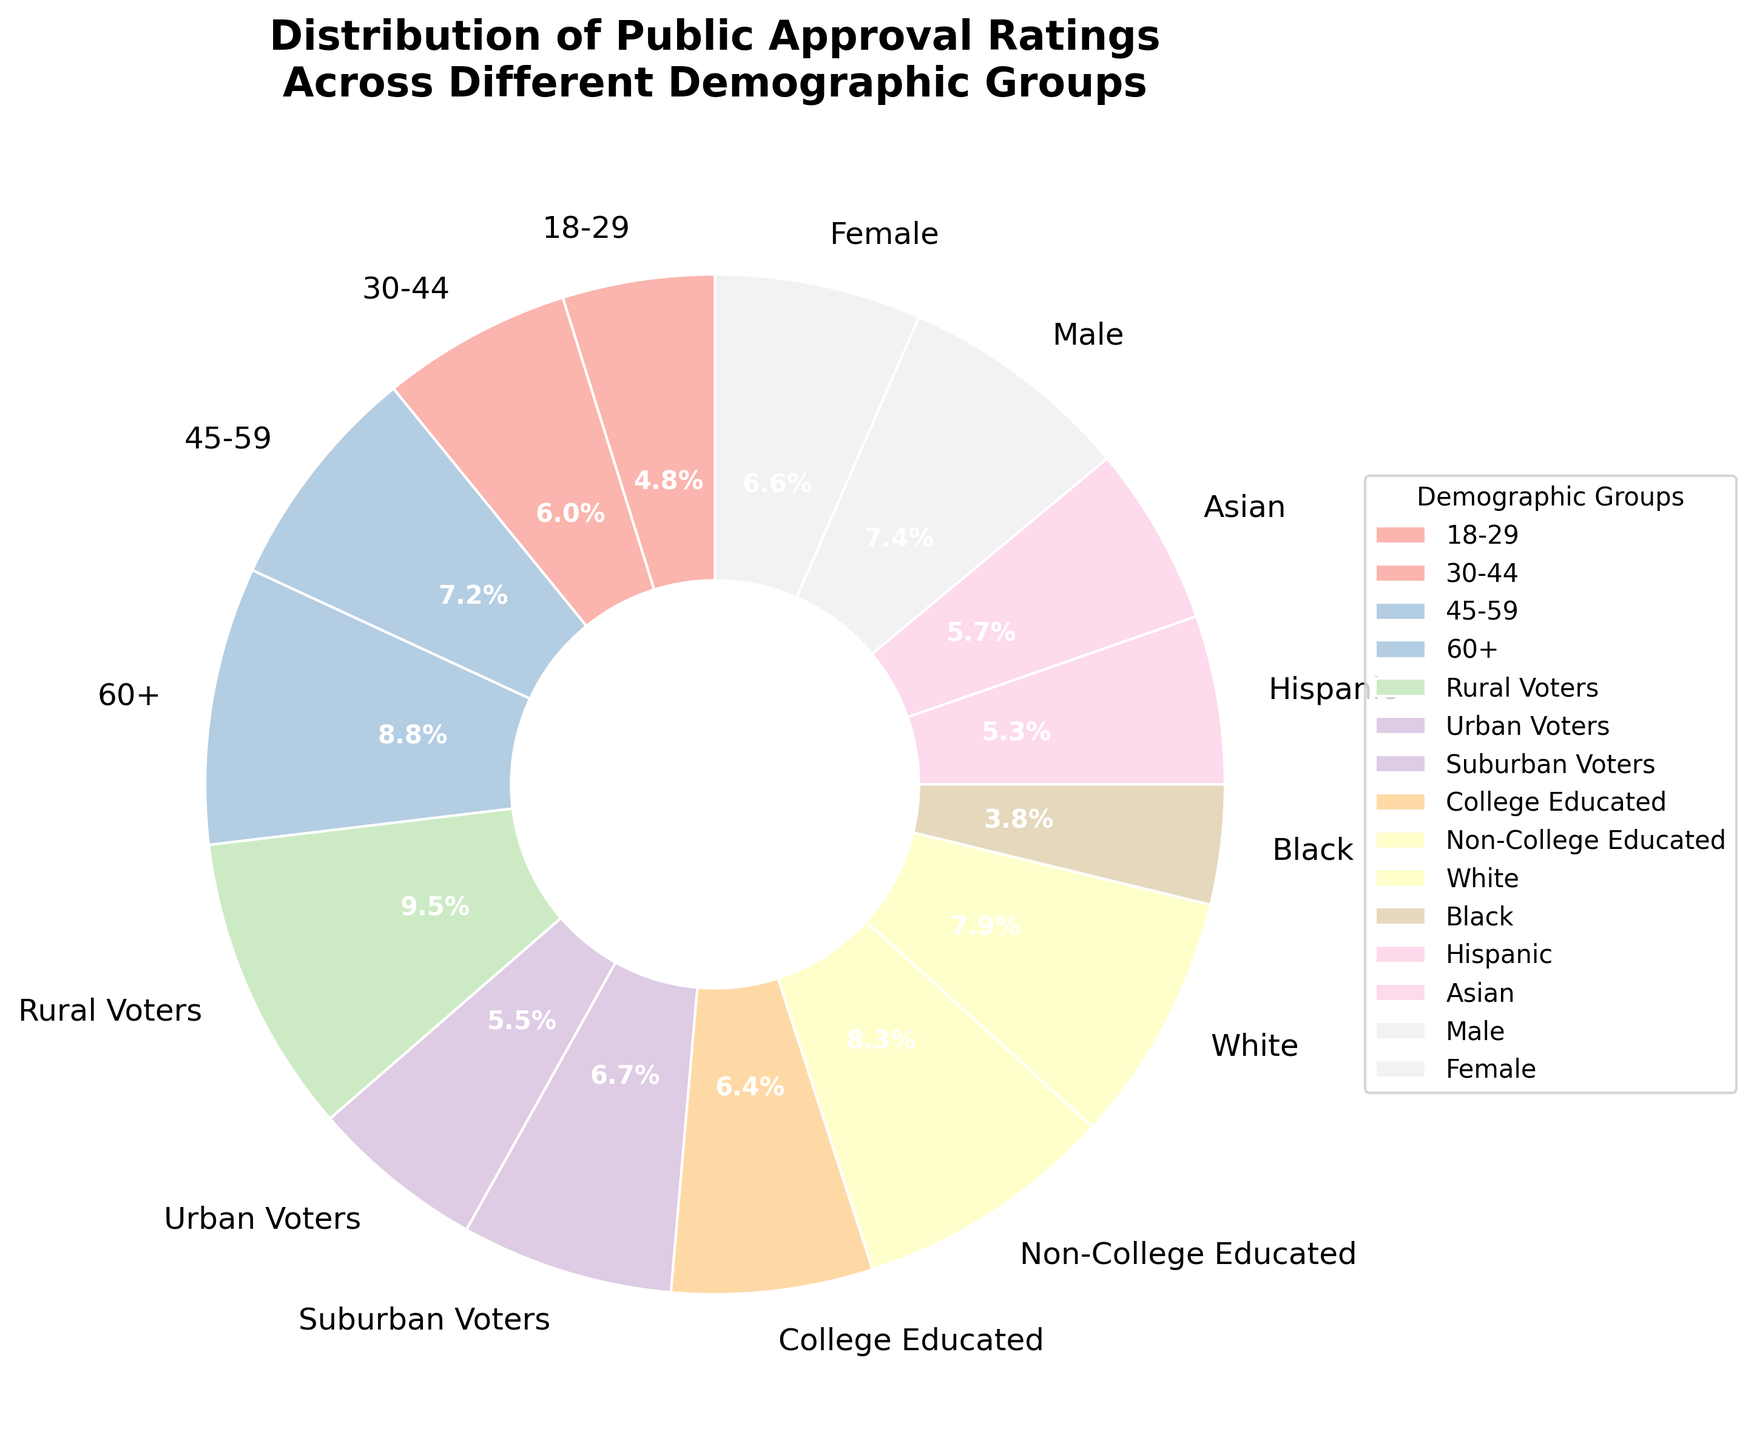What's the approval rating of Rural Voters? The pie chart segment labeled "Rural Voters" shows a percentage of 55%.
Answer: 55% Which demographic group has the highest approval rating? By examining the segments of the pie chart, the "Rural Voters" segment is the largest, representing the highest approval rating at 55%.
Answer: Rural Voters How does the approval rating of Urban Voters compare to that of Suburban Voters? The pie chart shows Urban Voters have a 32% approval rating and Suburban Voters have 39%. Comparing these values, Suburban Voters have a higher approval rating.
Answer: Suburban Voters have a higher approval rating What's the approval rating difference between Male and Female demographics? The approval rating for Males is 43%, and for Females, it is 38%. The difference is 43% - 38% = 5%.
Answer: 5% What's the average approval rating for the age groups (18-29, 30-44, 45-59, 60+)? The approval ratings for the age groups are 28%, 35%, 42%, and 51%. The average is calculated as (28 + 35 + 42 + 51) / 4 = 156 / 4 = 39%.
Answer: 39% Which demographic group has the lowest approval rating? Observing the smallest pie chart segment reveals "Black" has the smallest percentage at 22%.
Answer: Black What is the approval rating of the Non-College Educated compared to the College Educated? The pie chart shows Non-College Educated with 48% and College Educated with 37%. The Non-College Educated have a higher approval rating.
Answer: Non-College Educated have a higher approval rating Combine the approval ratings of the Hispanic and Asian demographics. What is the combined percentage? The approval rating for Hispanics is 31%, and for Asians, it is 33%. Adding these values gives 31% + 33% = 64%.
Answer: 64% What is the approval rating of the demographic labeled 'White'? The pie chart segment labeled "White" shows a percentage of 46%.
Answer: 46% Is the approval rating of any age group less than that of the Asian demographic? If so, which one(s)? The approval rating of the Asian demographic is 33%. The approval rating of the 18-29 age group is 28%, which is less than 33%.
Answer: 18-29 